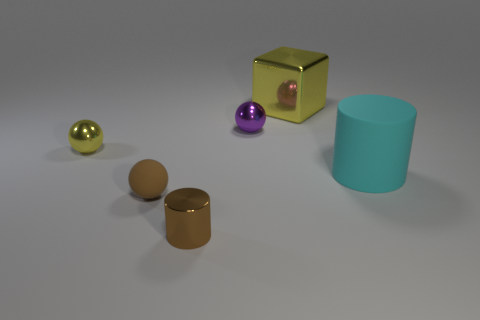Does the brown matte sphere have the same size as the yellow sphere?
Give a very brief answer. Yes. How many objects are things right of the big cube or tiny purple metal spheres?
Make the answer very short. 2. What material is the sphere in front of the tiny shiny sphere left of the small brown rubber object?
Offer a terse response. Rubber. Are there any yellow metallic objects that have the same shape as the large cyan thing?
Your response must be concise. No. Is the size of the yellow metal cube the same as the sphere that is on the right side of the small brown rubber object?
Provide a succinct answer. No. What number of things are either metallic objects in front of the large matte object or shiny things that are right of the purple sphere?
Keep it short and to the point. 2. Is the number of metal cylinders that are left of the purple metallic ball greater than the number of rubber things?
Provide a succinct answer. No. What number of other cyan objects have the same size as the cyan rubber thing?
Keep it short and to the point. 0. There is a yellow object that is on the right side of the brown matte sphere; is it the same size as the matte object that is on the right side of the shiny cylinder?
Your response must be concise. Yes. What size is the brown object behind the tiny cylinder?
Offer a terse response. Small. 